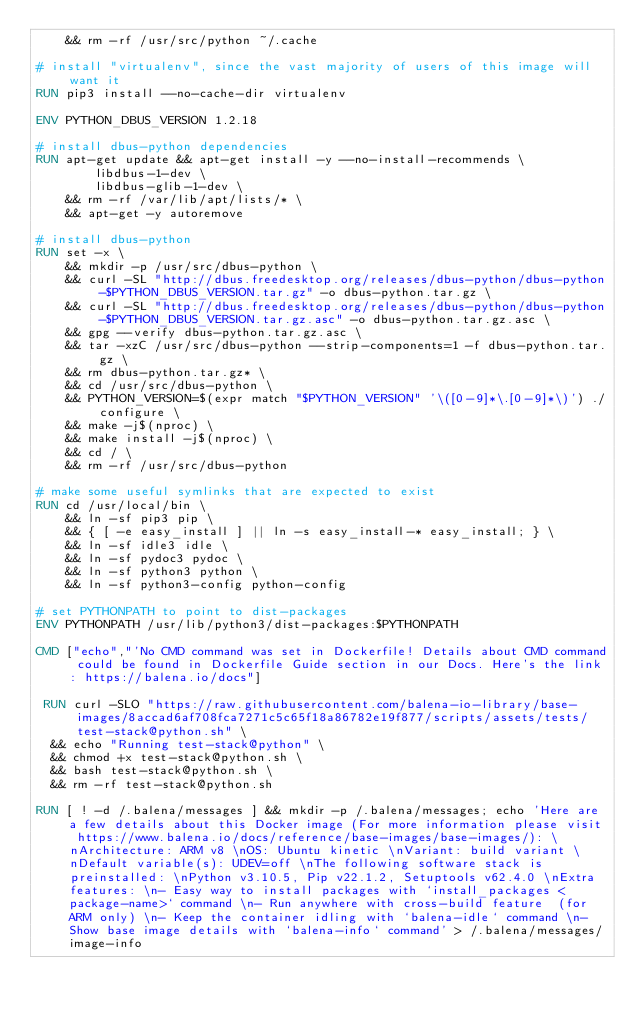<code> <loc_0><loc_0><loc_500><loc_500><_Dockerfile_>	&& rm -rf /usr/src/python ~/.cache

# install "virtualenv", since the vast majority of users of this image will want it
RUN pip3 install --no-cache-dir virtualenv

ENV PYTHON_DBUS_VERSION 1.2.18

# install dbus-python dependencies 
RUN apt-get update && apt-get install -y --no-install-recommends \
		libdbus-1-dev \
		libdbus-glib-1-dev \
	&& rm -rf /var/lib/apt/lists/* \
	&& apt-get -y autoremove

# install dbus-python
RUN set -x \
	&& mkdir -p /usr/src/dbus-python \
	&& curl -SL "http://dbus.freedesktop.org/releases/dbus-python/dbus-python-$PYTHON_DBUS_VERSION.tar.gz" -o dbus-python.tar.gz \
	&& curl -SL "http://dbus.freedesktop.org/releases/dbus-python/dbus-python-$PYTHON_DBUS_VERSION.tar.gz.asc" -o dbus-python.tar.gz.asc \
	&& gpg --verify dbus-python.tar.gz.asc \
	&& tar -xzC /usr/src/dbus-python --strip-components=1 -f dbus-python.tar.gz \
	&& rm dbus-python.tar.gz* \
	&& cd /usr/src/dbus-python \
	&& PYTHON_VERSION=$(expr match "$PYTHON_VERSION" '\([0-9]*\.[0-9]*\)') ./configure \
	&& make -j$(nproc) \
	&& make install -j$(nproc) \
	&& cd / \
	&& rm -rf /usr/src/dbus-python

# make some useful symlinks that are expected to exist
RUN cd /usr/local/bin \
	&& ln -sf pip3 pip \
	&& { [ -e easy_install ] || ln -s easy_install-* easy_install; } \
	&& ln -sf idle3 idle \
	&& ln -sf pydoc3 pydoc \
	&& ln -sf python3 python \
	&& ln -sf python3-config python-config

# set PYTHONPATH to point to dist-packages
ENV PYTHONPATH /usr/lib/python3/dist-packages:$PYTHONPATH

CMD ["echo","'No CMD command was set in Dockerfile! Details about CMD command could be found in Dockerfile Guide section in our Docs. Here's the link: https://balena.io/docs"]

 RUN curl -SLO "https://raw.githubusercontent.com/balena-io-library/base-images/8accad6af708fca7271c5c65f18a86782e19f877/scripts/assets/tests/test-stack@python.sh" \
  && echo "Running test-stack@python" \
  && chmod +x test-stack@python.sh \
  && bash test-stack@python.sh \
  && rm -rf test-stack@python.sh 

RUN [ ! -d /.balena/messages ] && mkdir -p /.balena/messages; echo 'Here are a few details about this Docker image (For more information please visit https://www.balena.io/docs/reference/base-images/base-images/): \nArchitecture: ARM v8 \nOS: Ubuntu kinetic \nVariant: build variant \nDefault variable(s): UDEV=off \nThe following software stack is preinstalled: \nPython v3.10.5, Pip v22.1.2, Setuptools v62.4.0 \nExtra features: \n- Easy way to install packages with `install_packages <package-name>` command \n- Run anywhere with cross-build feature  (for ARM only) \n- Keep the container idling with `balena-idle` command \n- Show base image details with `balena-info` command' > /.balena/messages/image-info</code> 